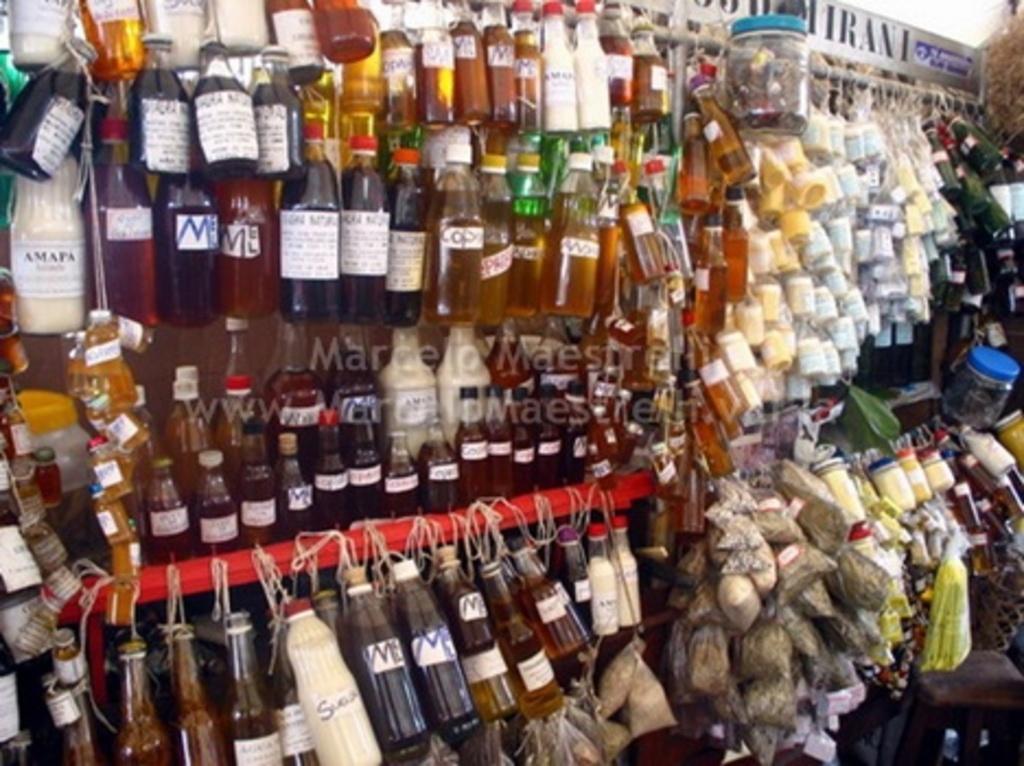Describe this image in one or two sentences. In this image I can see bottles. There are packets, containers and some other objects. 